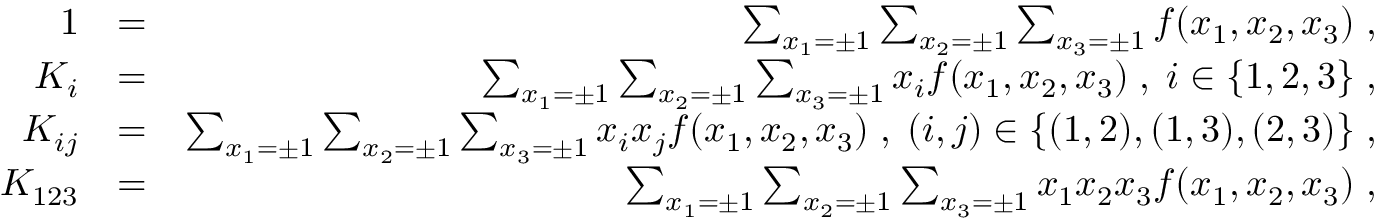Convert formula to latex. <formula><loc_0><loc_0><loc_500><loc_500>\begin{array} { r l r } { 1 } & { = } & { \sum _ { x _ { 1 } = \pm 1 } \sum _ { x _ { 2 } = \pm 1 } \sum _ { x _ { 3 } = \pm 1 } f ( x _ { 1 } , x _ { 2 } , x _ { 3 } ) \, , } \\ { K _ { i } } & { = } & { \sum _ { x _ { 1 } = \pm 1 } \sum _ { x _ { 2 } = \pm 1 } \sum _ { x _ { 3 } = \pm 1 } x _ { i } f ( x _ { 1 } , x _ { 2 } , x _ { 3 } ) \, , \, i \in \{ 1 , 2 , 3 \} \, , } \\ { K _ { i j } } & { = } & { \sum _ { x _ { 1 } = \pm 1 } \sum _ { x _ { 2 } = \pm 1 } \sum _ { x _ { 3 } = \pm 1 } x _ { i } x _ { j } f ( x _ { 1 } , x _ { 2 } , x _ { 3 } ) \, , \, ( i , j ) \in \{ ( 1 , 2 ) , ( 1 , 3 ) , ( 2 , 3 ) \} \, , } \\ { K _ { 1 2 3 } } & { = } & { \sum _ { x _ { 1 } = \pm 1 } \sum _ { x _ { 2 } = \pm 1 } \sum _ { x _ { 3 } = \pm 1 } x _ { 1 } x _ { 2 } x _ { 3 } f ( x _ { 1 } , x _ { 2 } , x _ { 3 } ) \, , } \end{array}</formula> 